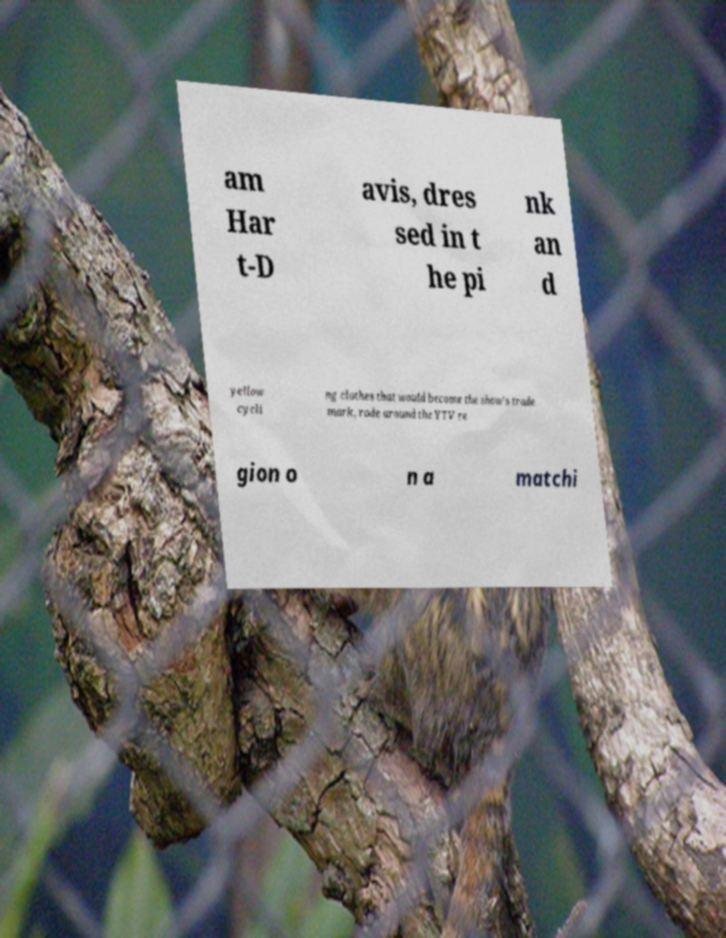For documentation purposes, I need the text within this image transcribed. Could you provide that? am Har t-D avis, dres sed in t he pi nk an d yellow cycli ng clothes that would become the show's trade mark, rode around the YTV re gion o n a matchi 